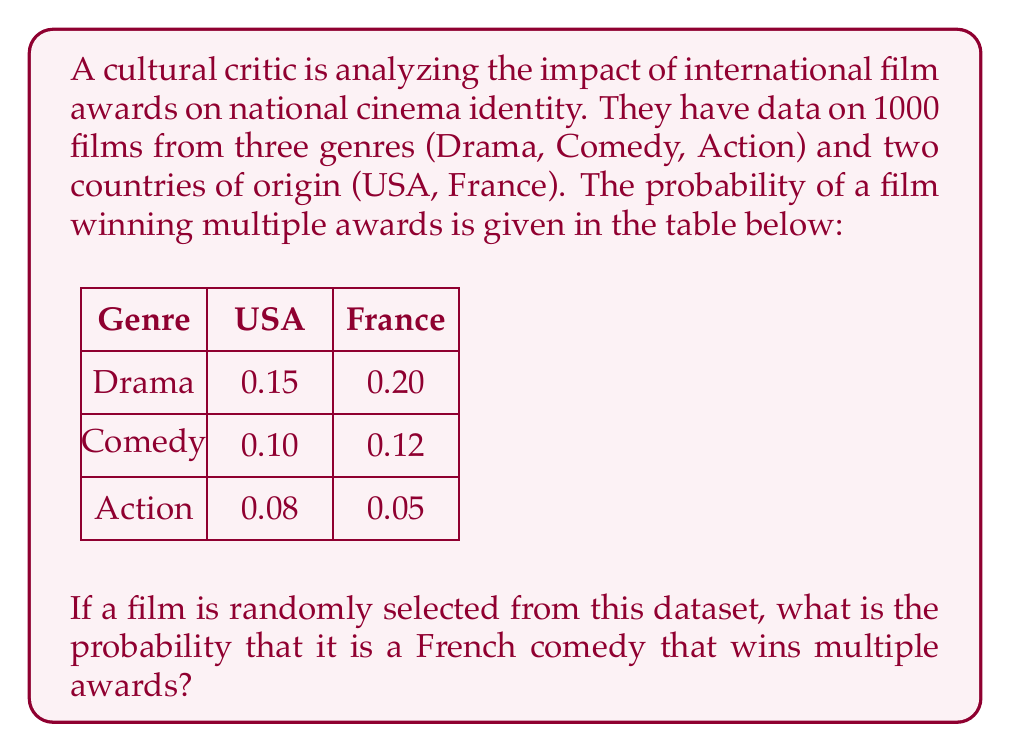Teach me how to tackle this problem. To solve this problem, we need to use the concept of conditional probability and the given information. Let's break it down step by step:

1) First, we need to find the probability of a film being French. Since we have 1000 films total, and they come from two countries, we can assume an equal distribution:

   $P(\text{French}) = 0.5$

2) Next, we need to find the probability of a film being a comedy. There are three genres, so assuming equal distribution:

   $P(\text{Comedy}) = \frac{1}{3}$

3) The probability of a French comedy winning multiple awards is given in the table:

   $P(\text{Multiple Awards} | \text{French Comedy}) = 0.12$

4) Now, we can use the multiplication rule of probability to find the probability of all these events occurring together:

   $P(\text{French} \cap \text{Comedy} \cap \text{Multiple Awards}) = P(\text{French}) \times P(\text{Comedy}) \times P(\text{Multiple Awards} | \text{French Comedy})$

5) Substituting the values:

   $P(\text{French} \cap \text{Comedy} \cap \text{Multiple Awards}) = 0.5 \times \frac{1}{3} \times 0.12$

6) Calculating:

   $P(\text{French} \cap \text{Comedy} \cap \text{Multiple Awards}) = 0.02$

Therefore, the probability of randomly selecting a French comedy that wins multiple awards is 0.02 or 2%.
Answer: $0.02$ 